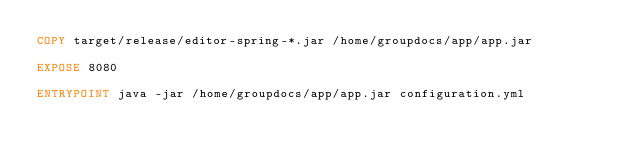<code> <loc_0><loc_0><loc_500><loc_500><_Dockerfile_>COPY target/release/editor-spring-*.jar /home/groupdocs/app/app.jar

EXPOSE 8080

ENTRYPOINT java -jar /home/groupdocs/app/app.jar configuration.yml</code> 